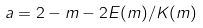<formula> <loc_0><loc_0><loc_500><loc_500>a = 2 - m - 2 E ( m ) / K ( m )</formula> 